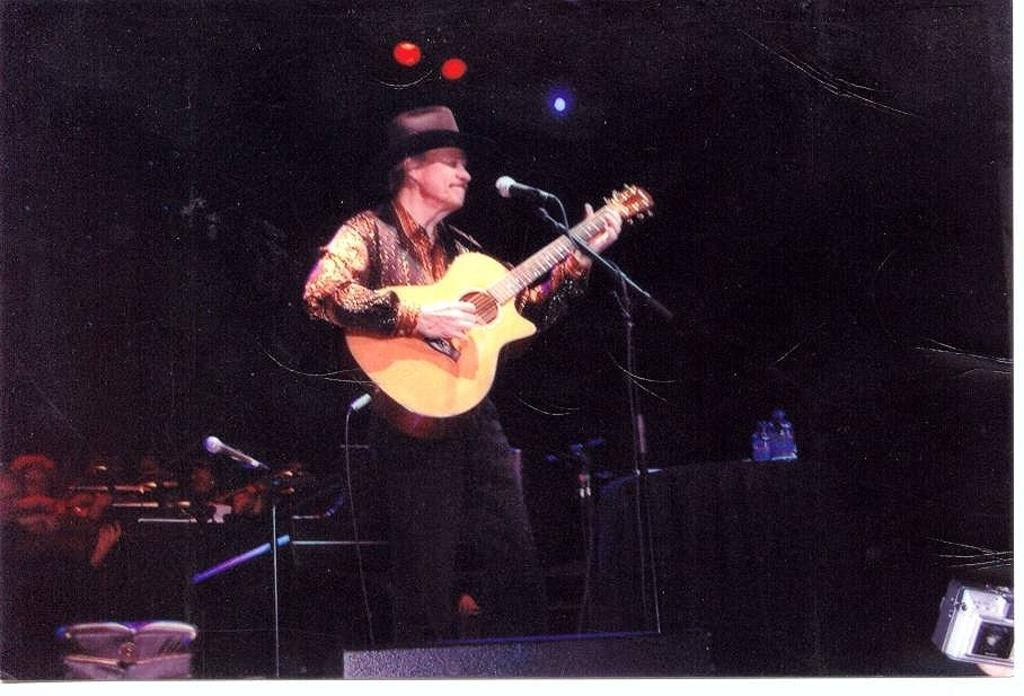What is the man in the center of the image doing? The man is playing a guitar. What is the man wearing on his head? The man is wearing a cap. What object is placed in front of the man? There is a microphone placed before the man. What can be seen at the top of the image? There are lights visible at the top of the image. How does the man's muscle help him play the guitar in the image? The image does not provide information about the man's muscles or their role in playing the guitar. 